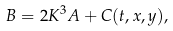<formula> <loc_0><loc_0><loc_500><loc_500>B = 2 K ^ { 3 } A + C ( t , x , y ) ,</formula> 